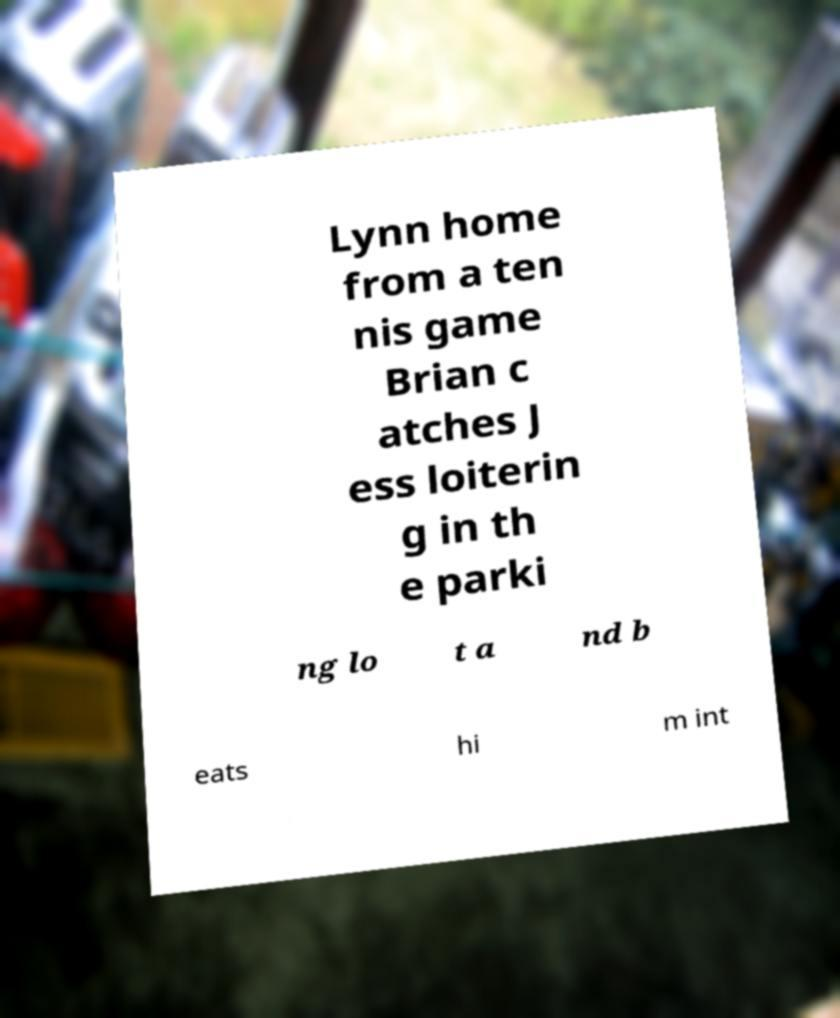Can you read and provide the text displayed in the image?This photo seems to have some interesting text. Can you extract and type it out for me? Lynn home from a ten nis game Brian c atches J ess loiterin g in th e parki ng lo t a nd b eats hi m int 